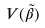Convert formula to latex. <formula><loc_0><loc_0><loc_500><loc_500>V ( \tilde { \beta } )</formula> 